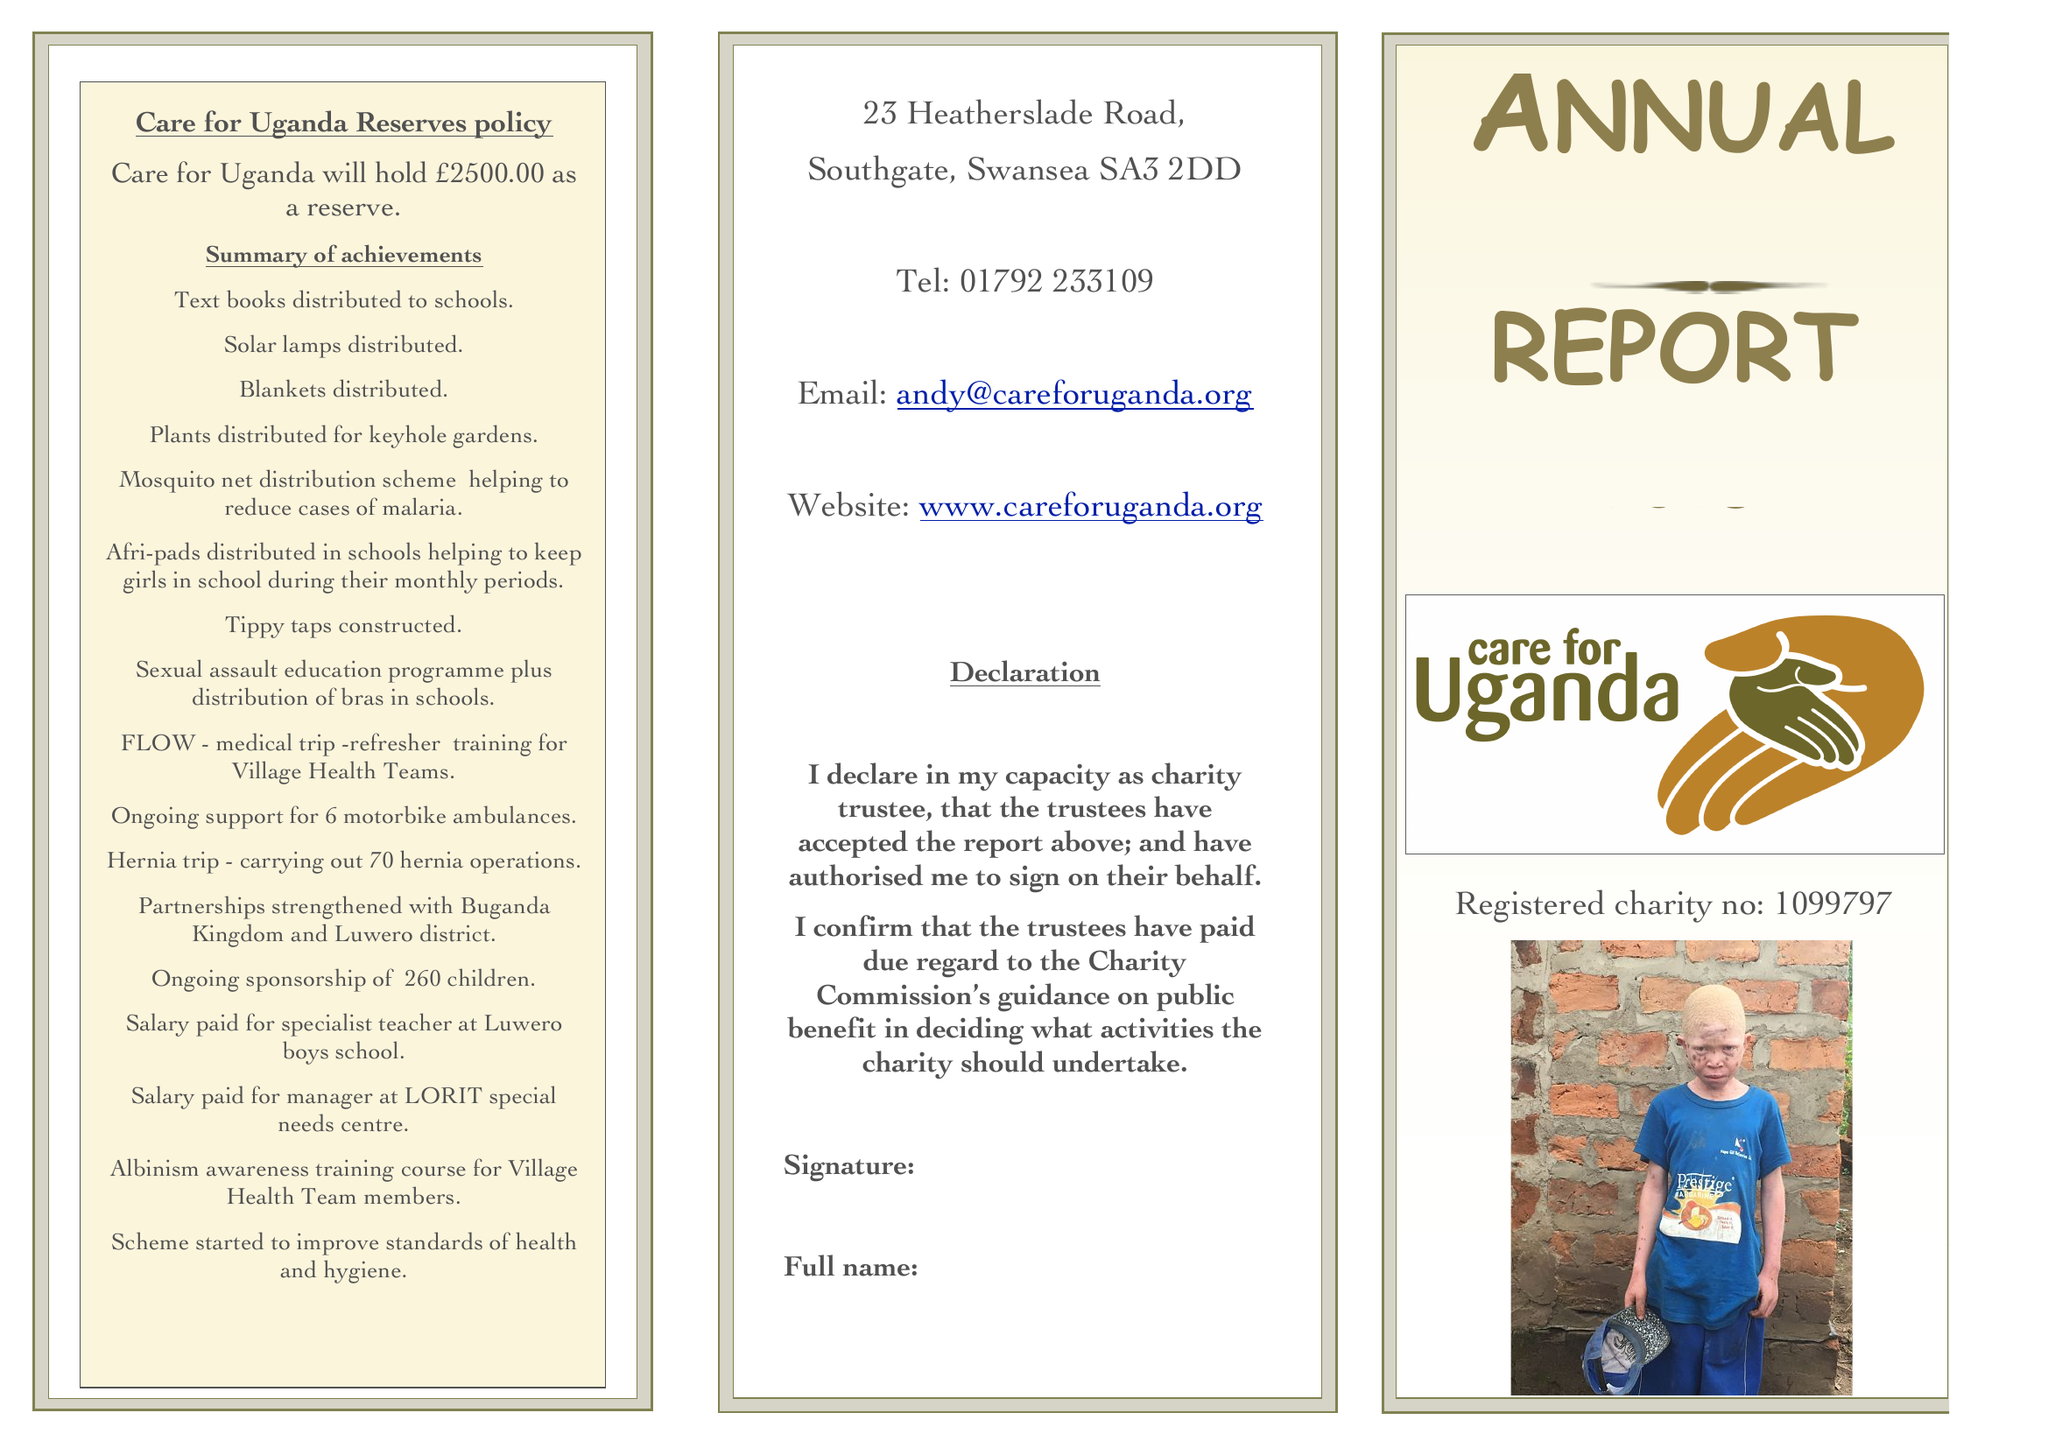What is the value for the spending_annually_in_british_pounds?
Answer the question using a single word or phrase. 102621.00 